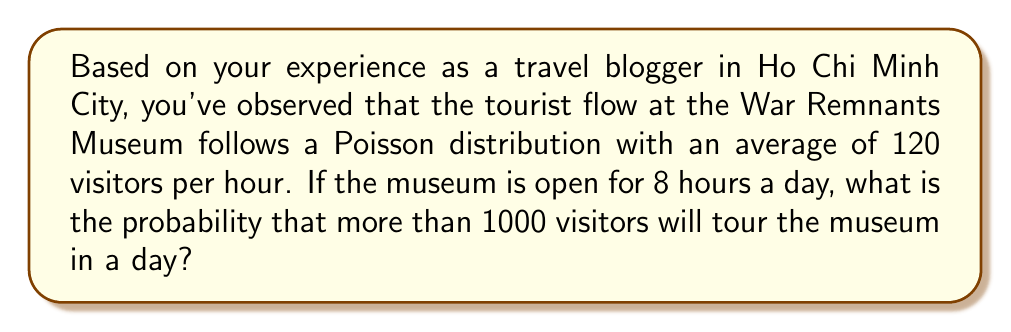What is the answer to this math problem? Let's approach this step-by-step:

1) First, we need to calculate the expected number of visitors per day:
   $\lambda_{day} = 120 \text{ visitors/hour} \times 8 \text{ hours} = 960 \text{ visitors/day}$

2) We're looking for the probability of more than 1000 visitors in a day. This is equivalent to the probability of 1001 or more visitors.

3) For a Poisson distribution with mean $\lambda$, the probability of $X$ or fewer events is given by the cumulative distribution function:

   $P(X \leq k) = e^{-\lambda} \sum_{i=0}^k \frac{\lambda^i}{i!}$

4) We want the probability of more than 1000 visitors, which is the complement of 1000 or fewer visitors:

   $P(X > 1000) = 1 - P(X \leq 1000)$

5) Using the Poisson CDF with $\lambda = 960$ and $k = 1000$:

   $P(X > 1000) = 1 - e^{-960} \sum_{i=0}^{1000} \frac{960^i}{i!}$

6) This calculation is complex to do by hand, so we typically use statistical software or calculators. Using such a tool, we get:

   $P(X > 1000) \approx 0.1056$

7) Converting to a percentage:

   $0.1056 \times 100\% \approx 10.56\%$
Answer: 10.56% 